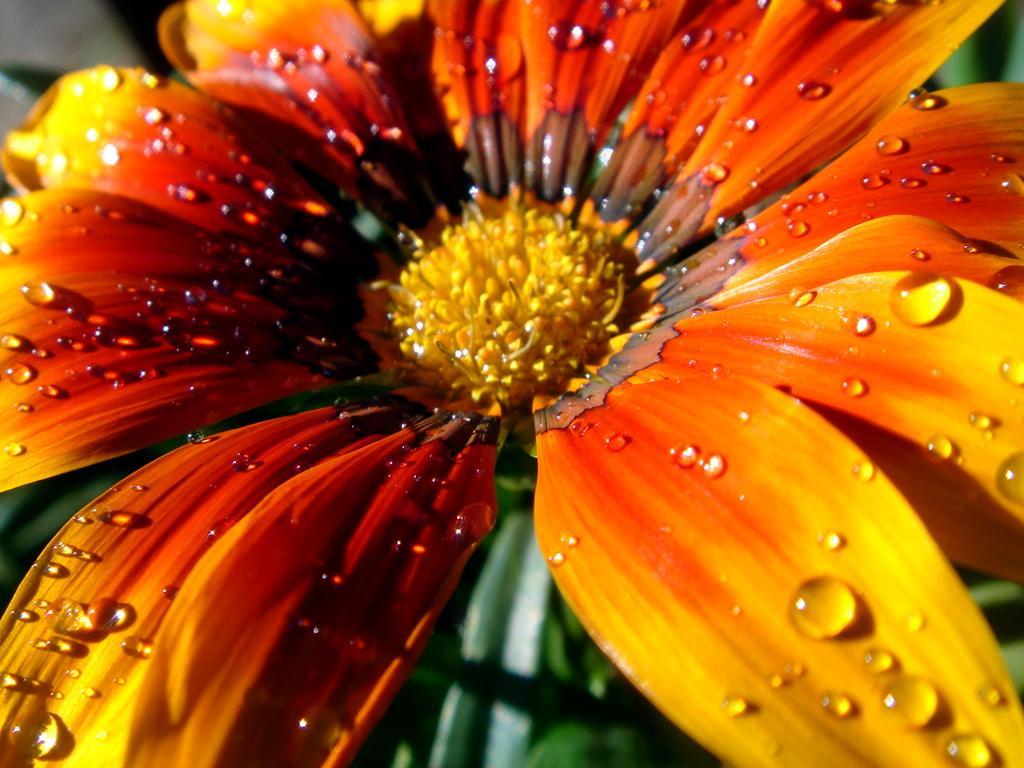Please provide a concise description of this image. In this picture we can see a flower with water droplets on it and in the background we can see leaves. 